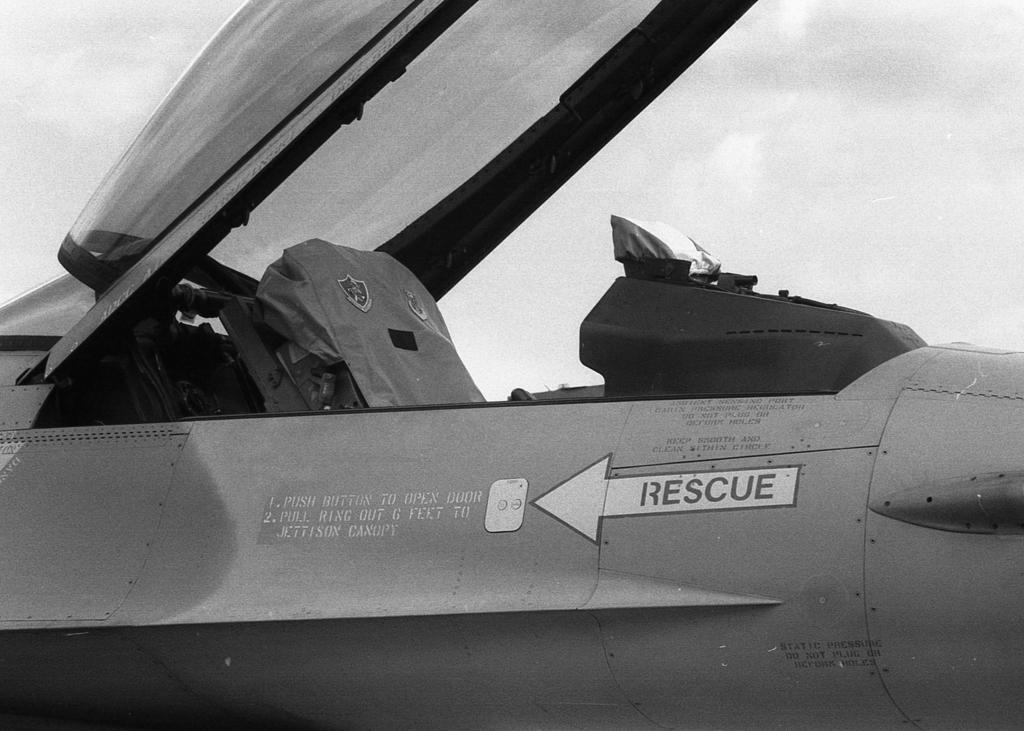What is the color scheme of the image? The image is black and white. What is the main subject in the center of the image? There is an aircraft in the center of the image. How many birds are in the flock flying above the aircraft in the image? There are no birds or flock present in the image; it only features an aircraft. What is the chance of winning a prize while looking at the image? There is no mention of a prize or chance in the image, as it only features an aircraft. 